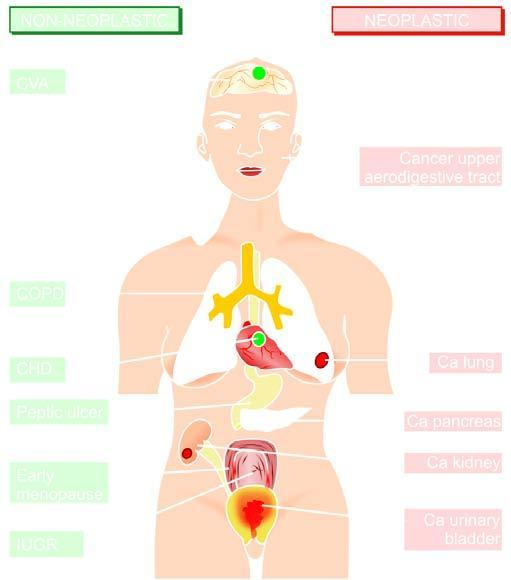what numbered serially in order of frequency of occurrence?
Answer the question using a single word or phrase. Non-neoplastic diseases 